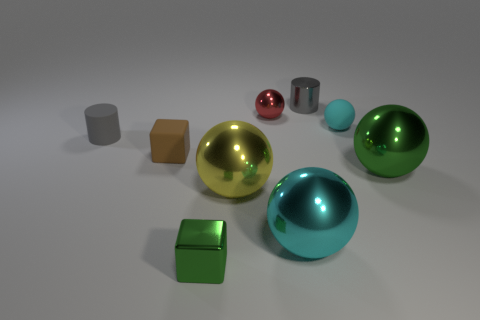Subtract all green cubes. Subtract all red spheres. How many cubes are left? 1 Add 1 large yellow balls. How many objects exist? 10 Subtract all cylinders. How many objects are left? 7 Add 2 tiny green cubes. How many tiny green cubes are left? 3 Add 6 shiny balls. How many shiny balls exist? 10 Subtract 0 blue cylinders. How many objects are left? 9 Subtract all cyan shiny balls. Subtract all small gray matte things. How many objects are left? 7 